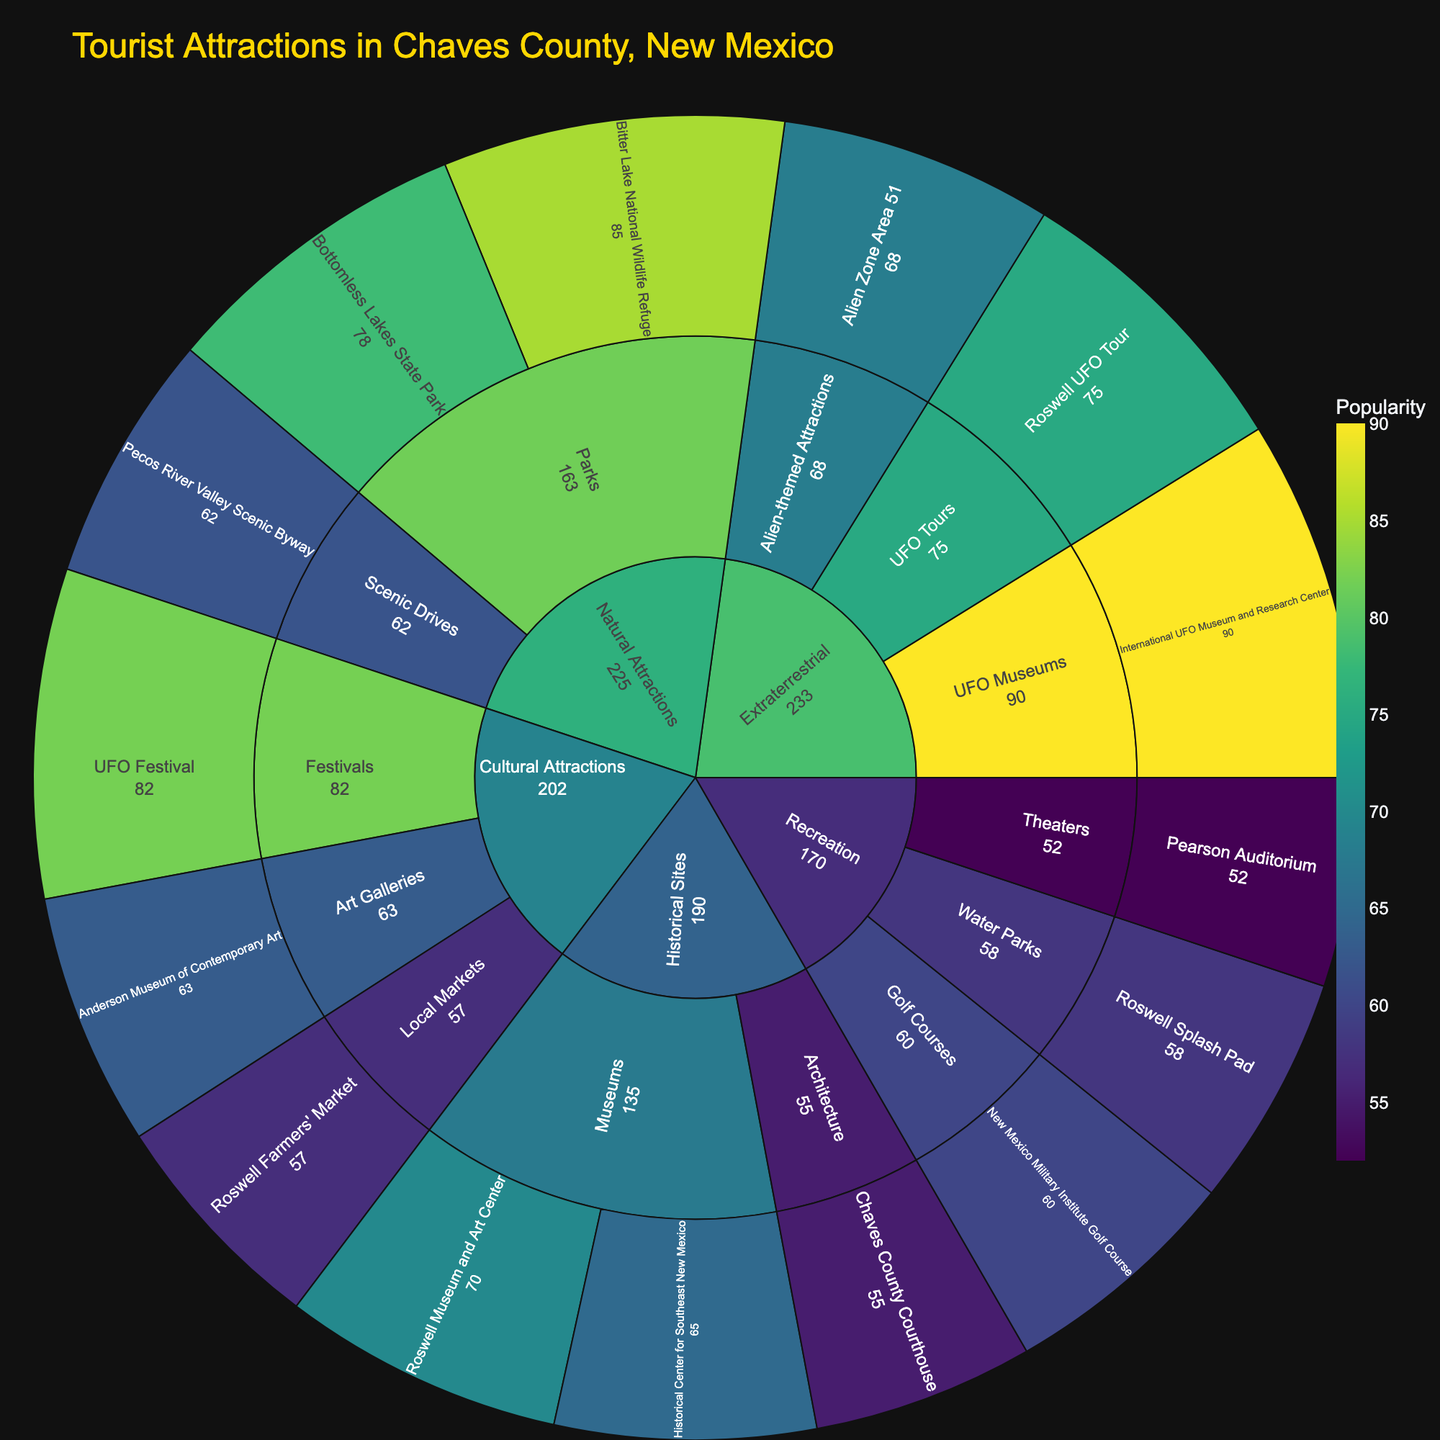What's the most popular attraction in Chaves County? The sunburst plot displays an International UFO Museum and Research Center at the outermost layer with the highest numerical value among all attractions.
Answer: International UFO Museum and Research Center Which category contains the attraction with the lowest popularity? The figure shows layers that branch out into subcategories and then into attractions with their respective popularity values. The "Recreation" category has Pearson Auditorium that shows the lowest value, which is 52.
Answer: Recreation How many categories are there in total? By looking at the central part of the sunburst plot, four main categories branch out from the center.
Answer: Four Which attraction under “Historical Sites” has a higher popularity, the Roswell Museum and Art Center or the Historical Center for Southeast New Mexico? The sunburst plot shows the popularity values for both attractions under the "Historical Sites" category. Cross-referencing the popularity values, the Roswell Museum and Art Center has a higher value (70) compared to the Historical Center for Southeast New Mexico (65).
Answer: Roswell Museum and Art Center What is the cumulative popularity of the attractions in the “Extraterrestrial” category? Summing up all the outermost values within the "Extraterrestrial" category, we get: 90 (International UFO Museum and Research Center) + 75 (Roswell UFO Tour) + 68 (Alien Zone Area 51). Adding these values gives us a total of 233.
Answer: 233 Which category has the most attractions listed? By counting the branches within each main category of the sunburst plot, "Natural Attractions" has 3, "Historical Sites" has 3, "Extraterrestrial" has 3, and "Recreation" has 3 subcategories. "Cultural Attractions" has 3 as well. There is a tie among all categories.
Answer: All categories are tied What is the average popularity of attractions in the “Natural Attractions” category? First, sum up the popularity values of the attractions in the "Natural Attractions" category: 85 (Bitter Lake National Wildlife Refuge) + 78 (Bottomless Lakes State Park) + 62 (Pecos River Valley Scenic Byway) = 225. Since there are 3 attractions, divide the total by 3, which equals 75.
Answer: 75 Which is more popular, the Roswell Splash Pad or the Roswell Farmers’ Market? The sunburst plot shows the popularity values for both attractions. The Roswell Splash Pad has a value of 58, and the Roswell Farmers' Market has a value of 57. Therefore, the Roswell Splash Pad is more popular.
Answer: Roswell Splash Pad What is the ratio of the most popular to the least popular attraction? The most popular attraction, International UFO Museum and Research Center, has a popularity of 90. The least popular attraction, Pearson Auditorium, has a popularity of 52. The ratio is 90/52, which simplifies to approximately 1.73.
Answer: 1.73 